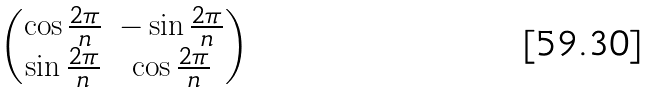<formula> <loc_0><loc_0><loc_500><loc_500>\begin{pmatrix} \cos \frac { 2 \pi } { n } & - \sin \frac { 2 \pi } { n } \\ \sin \frac { 2 \pi } { n } & \cos \frac { 2 \pi } { n } \end{pmatrix}</formula> 